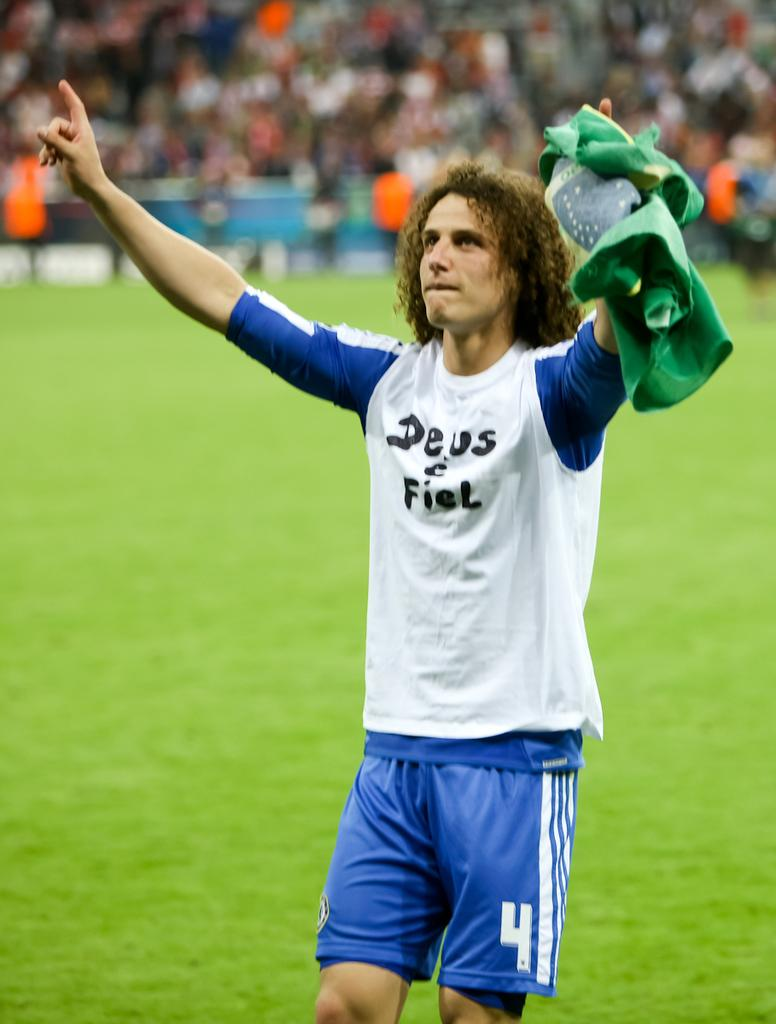What is the main subject of the image? There is a man in the image. What is the man holding in the image? The man is holding a cloth. What is the man's posture in the image? The man is standing. Can you describe the background of the image? The background of the image is blurred. What type of celery is the man using to clean the cloth in the image? There is no celery present in the image, and the man is not using any celery to clean the cloth. 